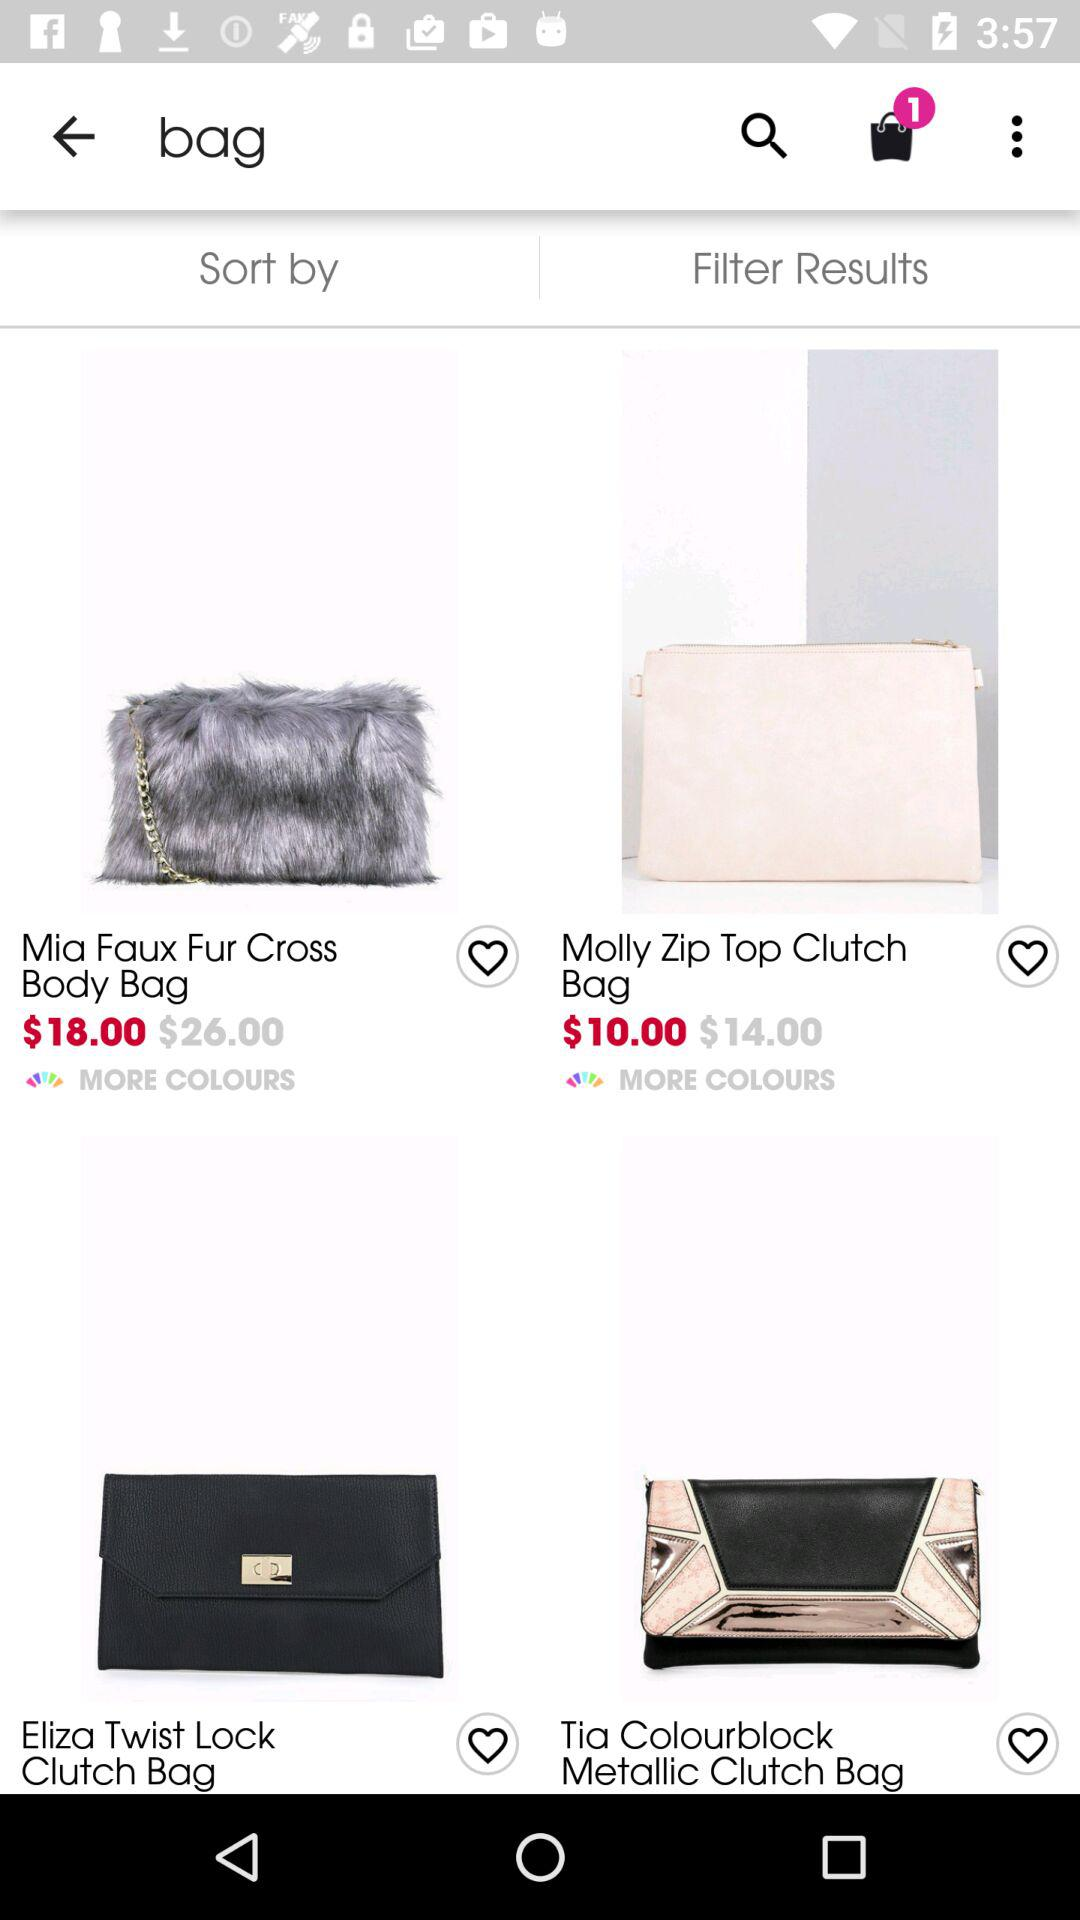How many items are in the bag? There is 1 item in the bag. 